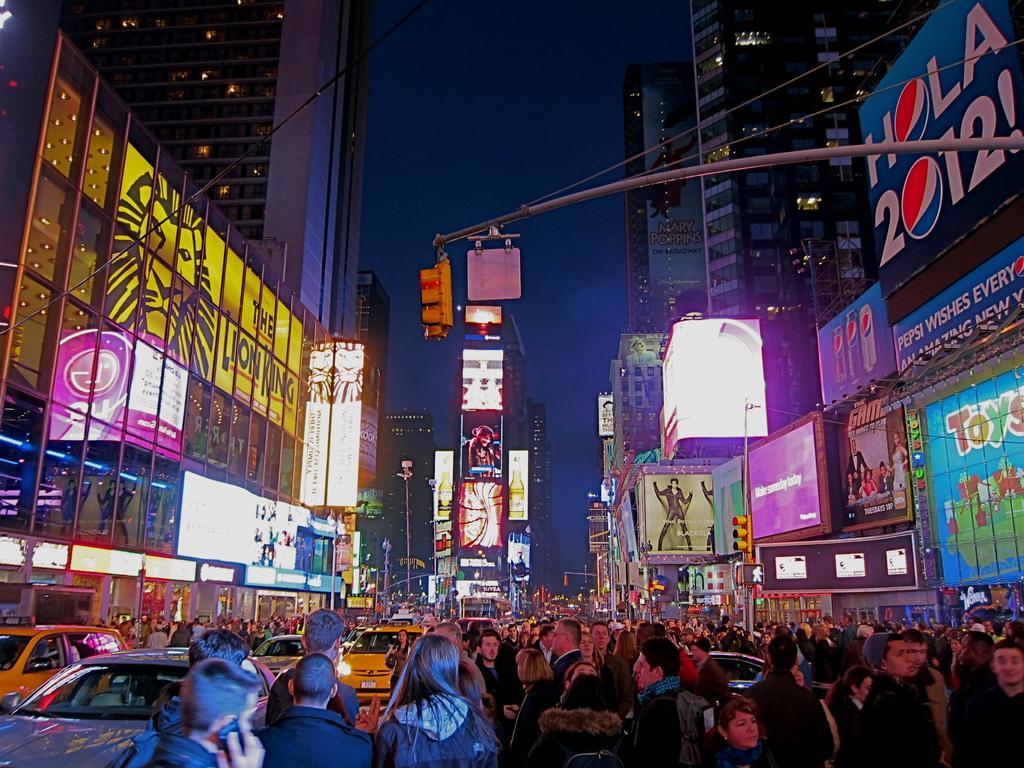Describe this image in one or two sentences. At the bottom of the image few people are standing. Behind them there are some vehicles. In the middle of the image there are some poles and buildings, on the buildings there are some banners. 